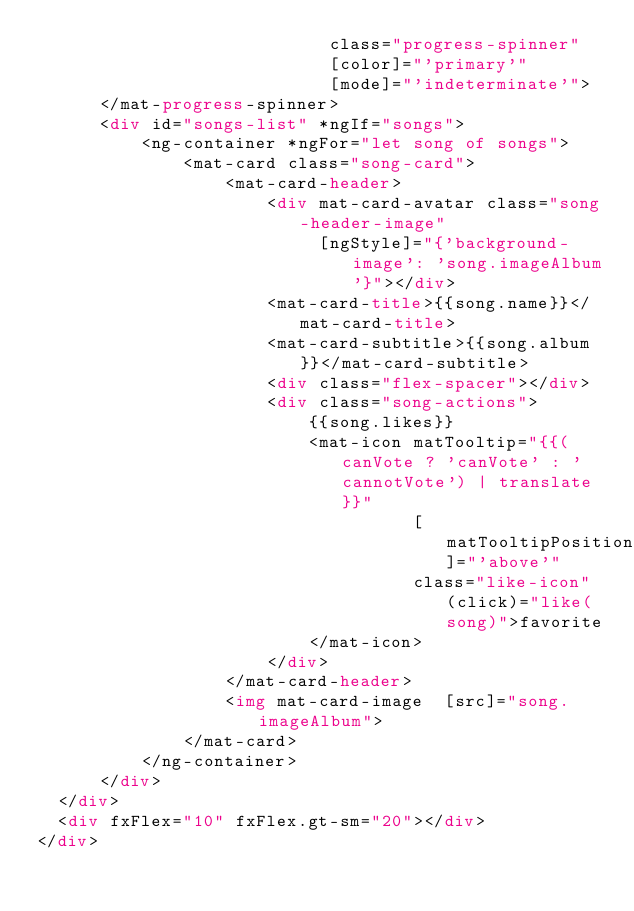<code> <loc_0><loc_0><loc_500><loc_500><_HTML_>                            class="progress-spinner"
                            [color]="'primary'"
                            [mode]="'indeterminate'">
      </mat-progress-spinner>
      <div id="songs-list" *ngIf="songs">
          <ng-container *ngFor="let song of songs">
              <mat-card class="song-card">
                  <mat-card-header>
                      <div mat-card-avatar class="song-header-image"
                           [ngStyle]="{'background-image': 'song.imageAlbum'}"></div>
                      <mat-card-title>{{song.name}}</mat-card-title>
                      <mat-card-subtitle>{{song.album}}</mat-card-subtitle>
                      <div class="flex-spacer"></div>
                      <div class="song-actions">
                          {{song.likes}}
                          <mat-icon matTooltip="{{(canVote ? 'canVote' : 'cannotVote') | translate}}"
                                    [matTooltipPosition]="'above'"
                                    class="like-icon" (click)="like(song)">favorite
                          </mat-icon>
                      </div>
                  </mat-card-header>
                  <img mat-card-image  [src]="song.imageAlbum">
              </mat-card>
          </ng-container>
      </div>
  </div>
  <div fxFlex="10" fxFlex.gt-sm="20"></div>
</div>
</code> 